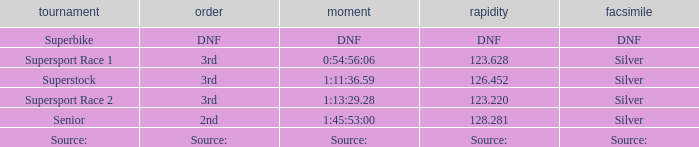Which race has a position of 3rd and a speed of 126.452? Superstock. 